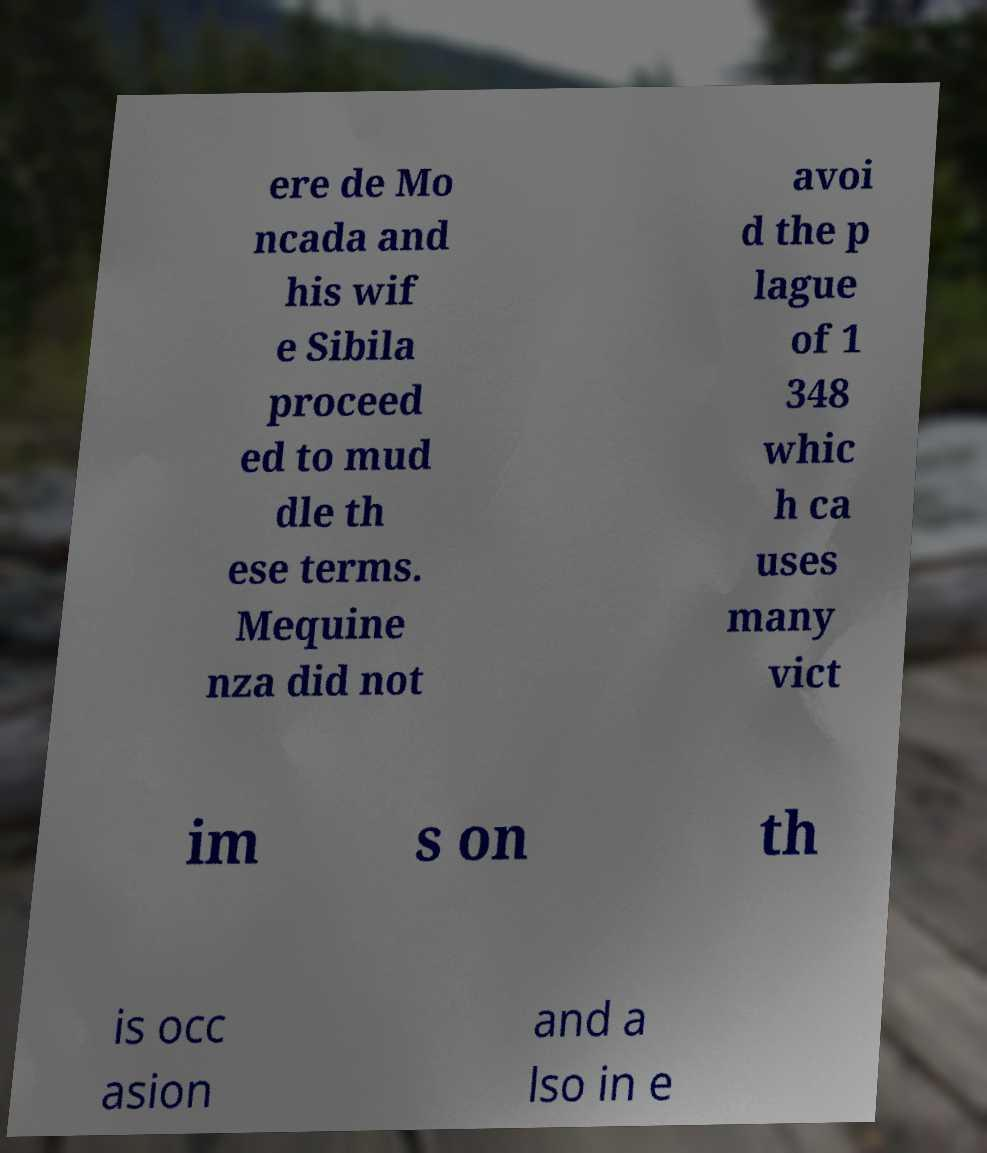There's text embedded in this image that I need extracted. Can you transcribe it verbatim? ere de Mo ncada and his wif e Sibila proceed ed to mud dle th ese terms. Mequine nza did not avoi d the p lague of 1 348 whic h ca uses many vict im s on th is occ asion and a lso in e 